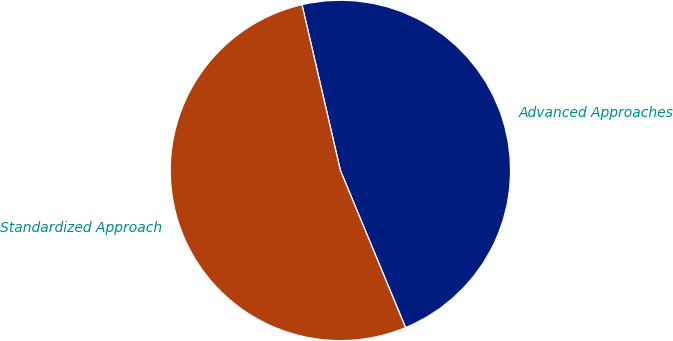Convert chart. <chart><loc_0><loc_0><loc_500><loc_500><pie_chart><fcel>Advanced Approaches<fcel>Standardized Approach<nl><fcel>47.37%<fcel>52.63%<nl></chart> 